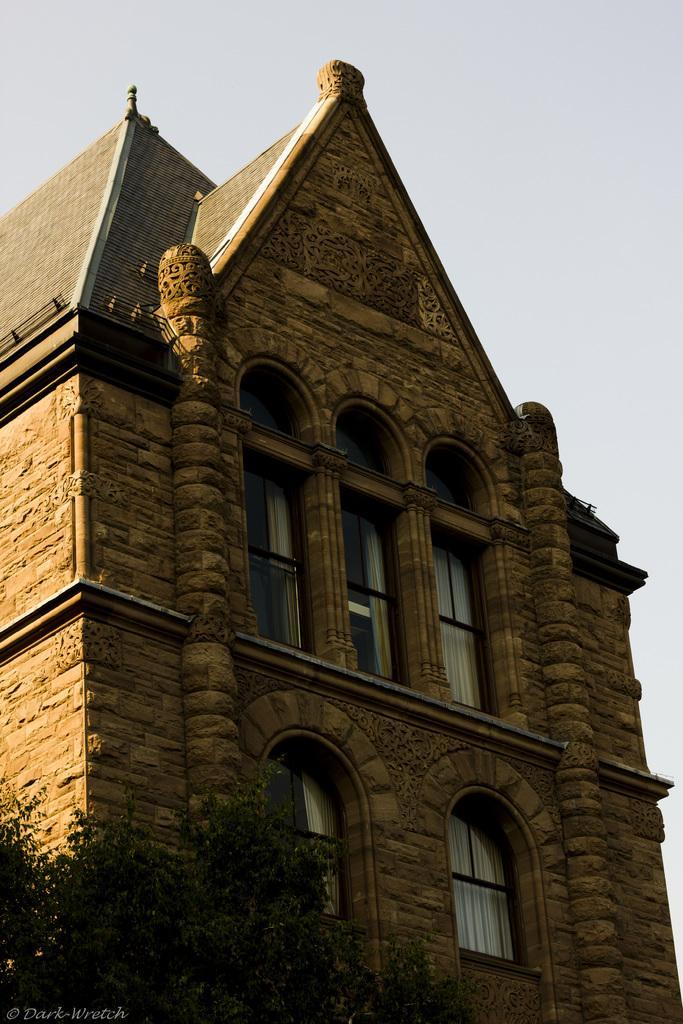In one or two sentences, can you explain what this image depicts? At the bottom left of the image there are trees. There is a building with walls, pillars, windows and roof. At the top of the image there is a sky. 